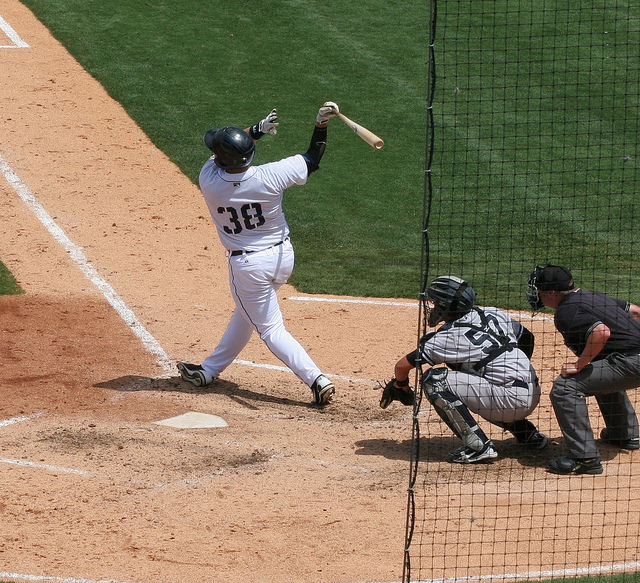Please identify all text content in this image. 38 57 